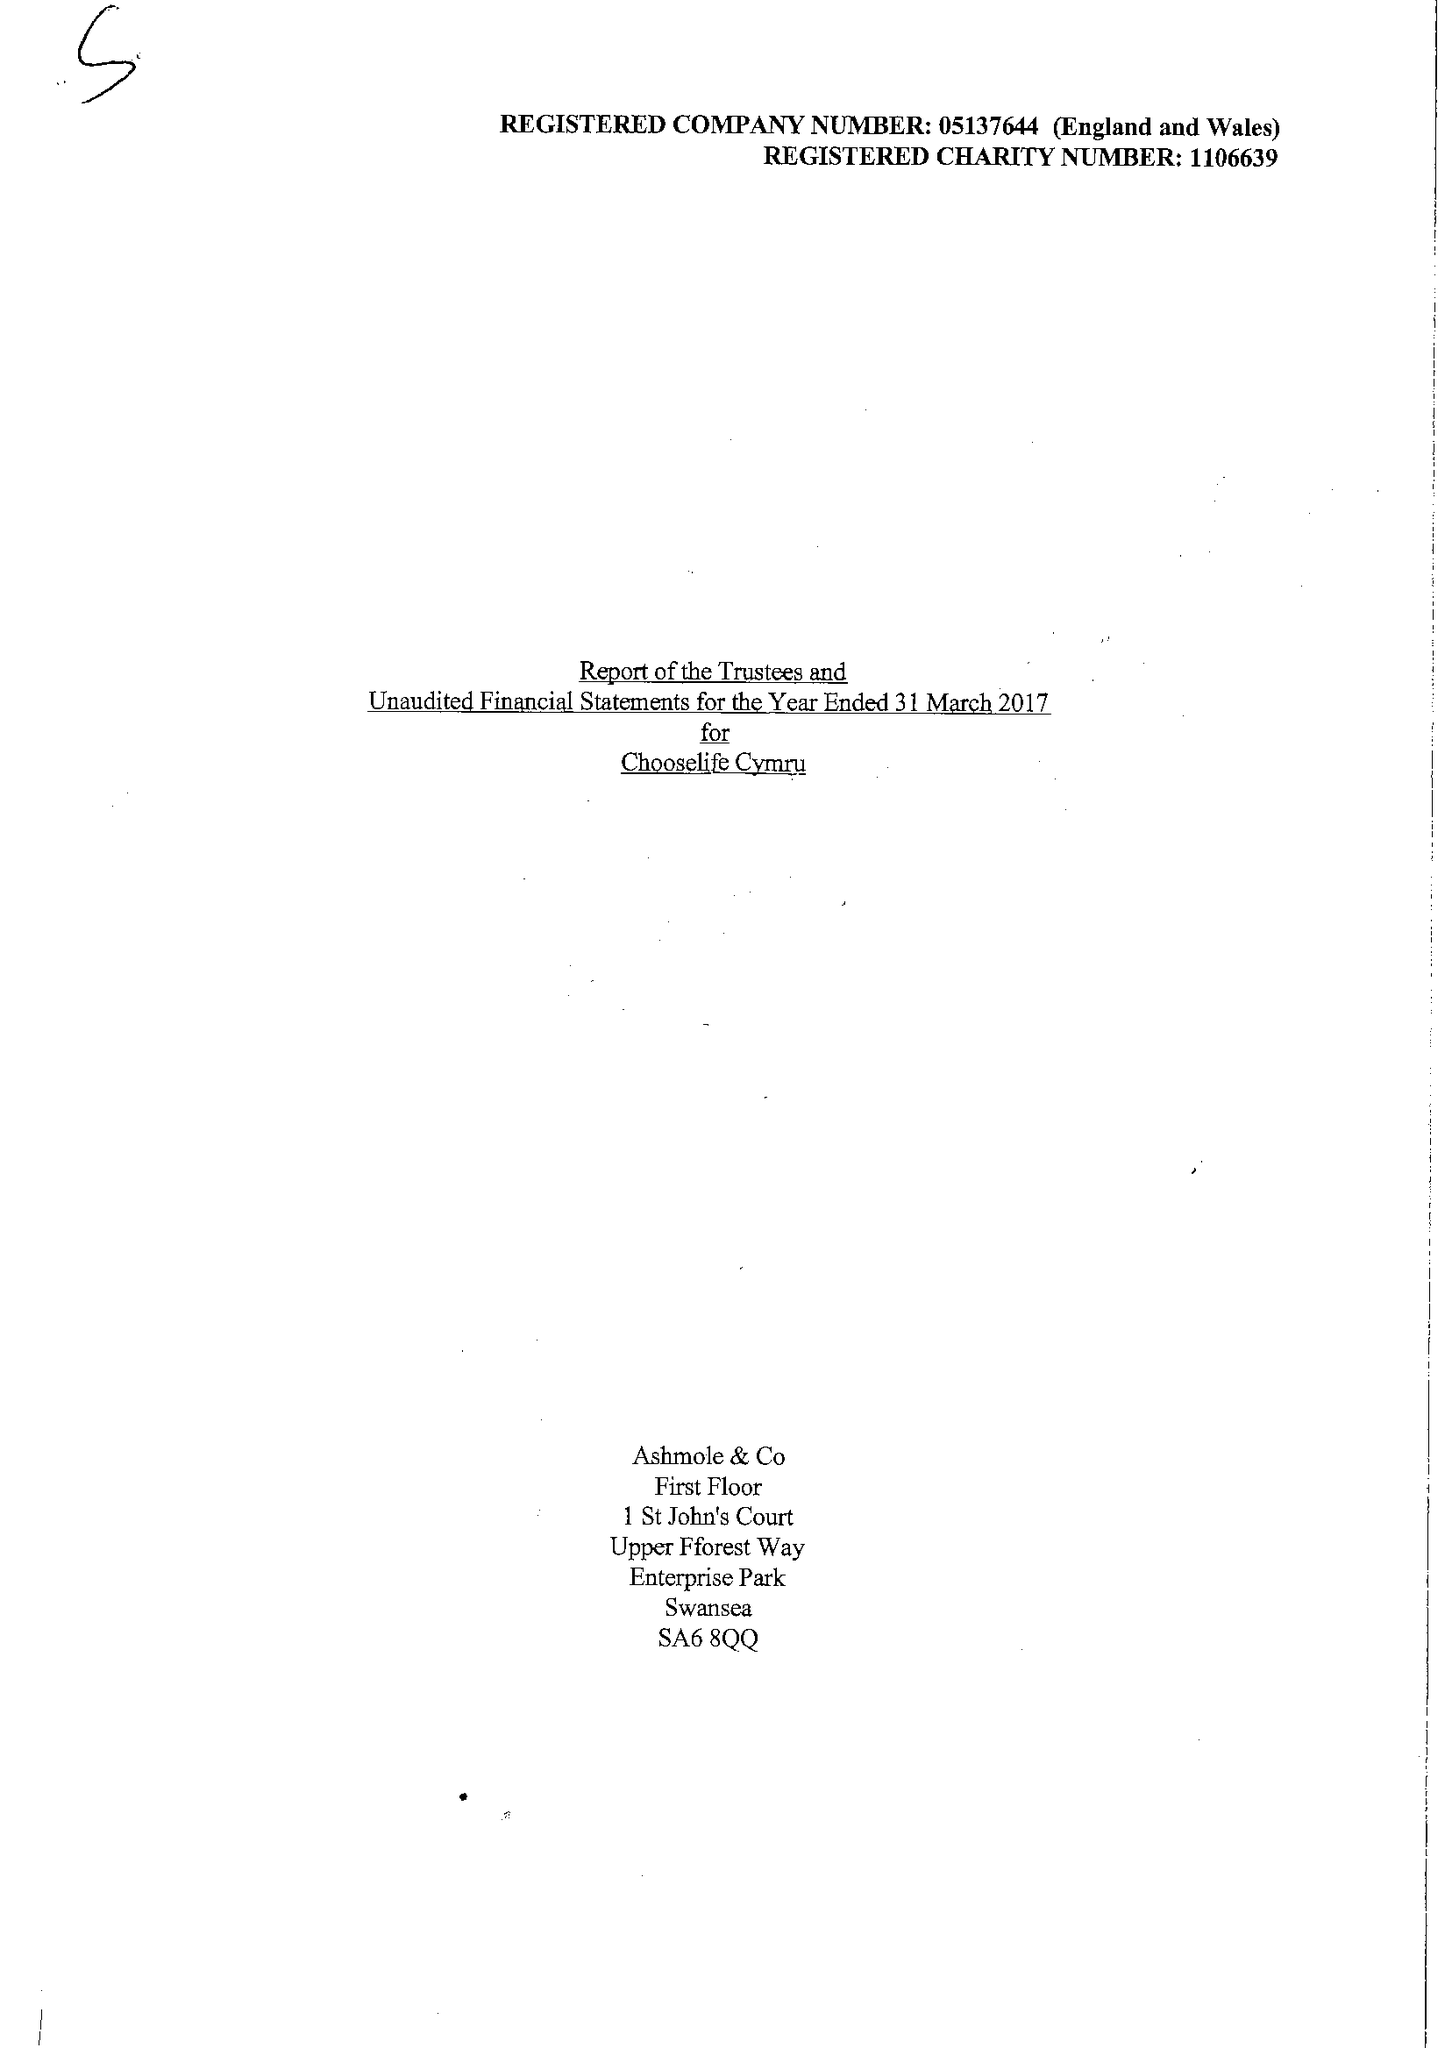What is the value for the charity_name?
Answer the question using a single word or phrase. Chooselife Cymru 